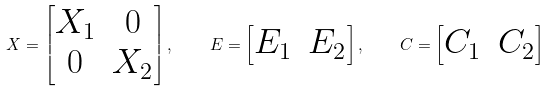<formula> <loc_0><loc_0><loc_500><loc_500>X = \begin{bmatrix} X _ { 1 } & 0 \\ 0 & X _ { 2 } \end{bmatrix} , \quad E = \begin{bmatrix} E _ { 1 } & E _ { 2 } \end{bmatrix} , \quad C = \begin{bmatrix} C _ { 1 } & C _ { 2 } \end{bmatrix}</formula> 